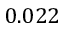<formula> <loc_0><loc_0><loc_500><loc_500>0 . 0 2 2</formula> 